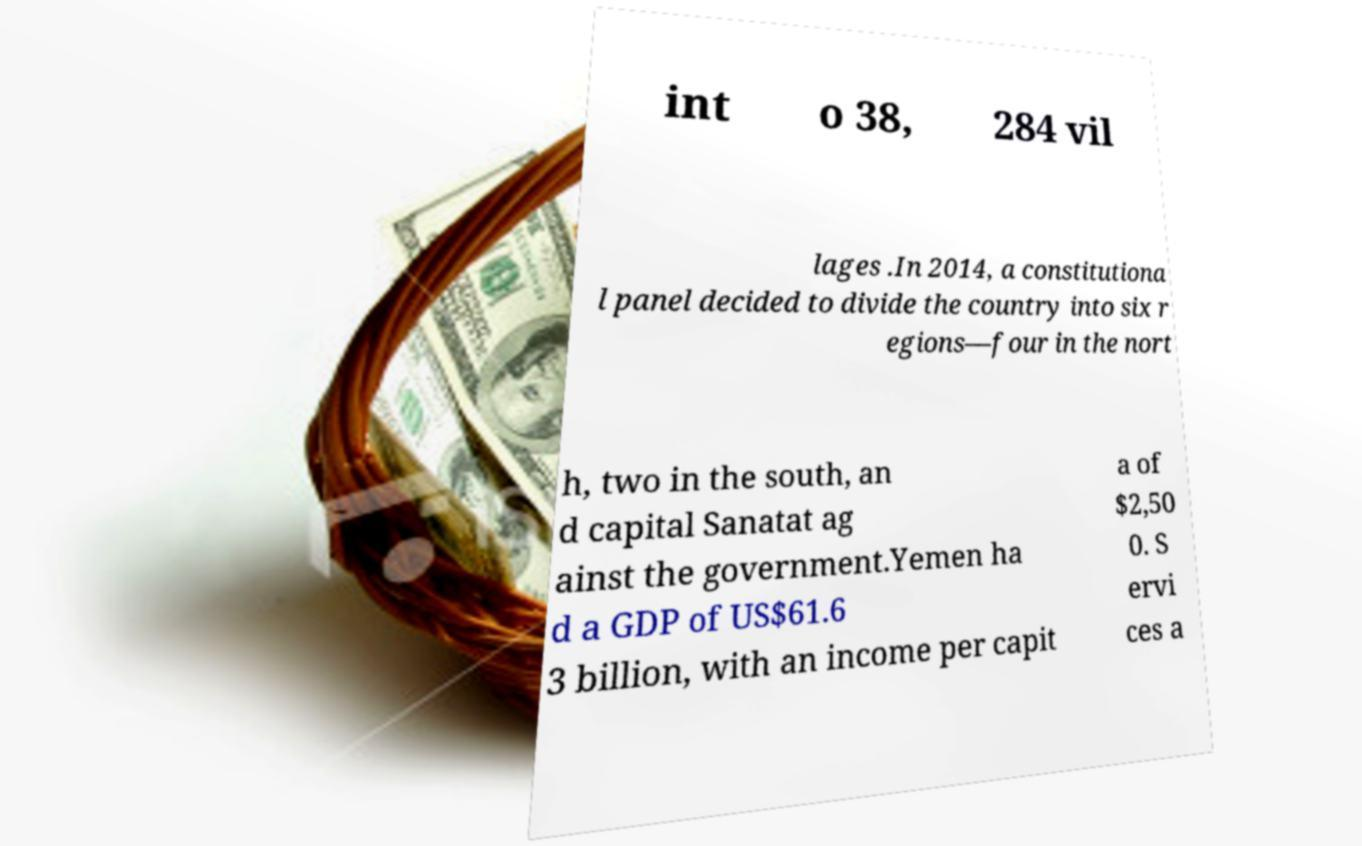Can you accurately transcribe the text from the provided image for me? int o 38, 284 vil lages .In 2014, a constitutiona l panel decided to divide the country into six r egions—four in the nort h, two in the south, an d capital Sanatat ag ainst the government.Yemen ha d a GDP of US$61.6 3 billion, with an income per capit a of $2,50 0. S ervi ces a 